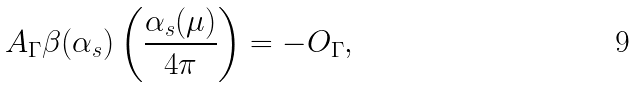Convert formula to latex. <formula><loc_0><loc_0><loc_500><loc_500>A _ { \Gamma } \beta ( \alpha _ { s } ) \left ( \frac { \alpha _ { s } ( \mu ) } { 4 \pi } \right ) = - O _ { \Gamma } ,</formula> 